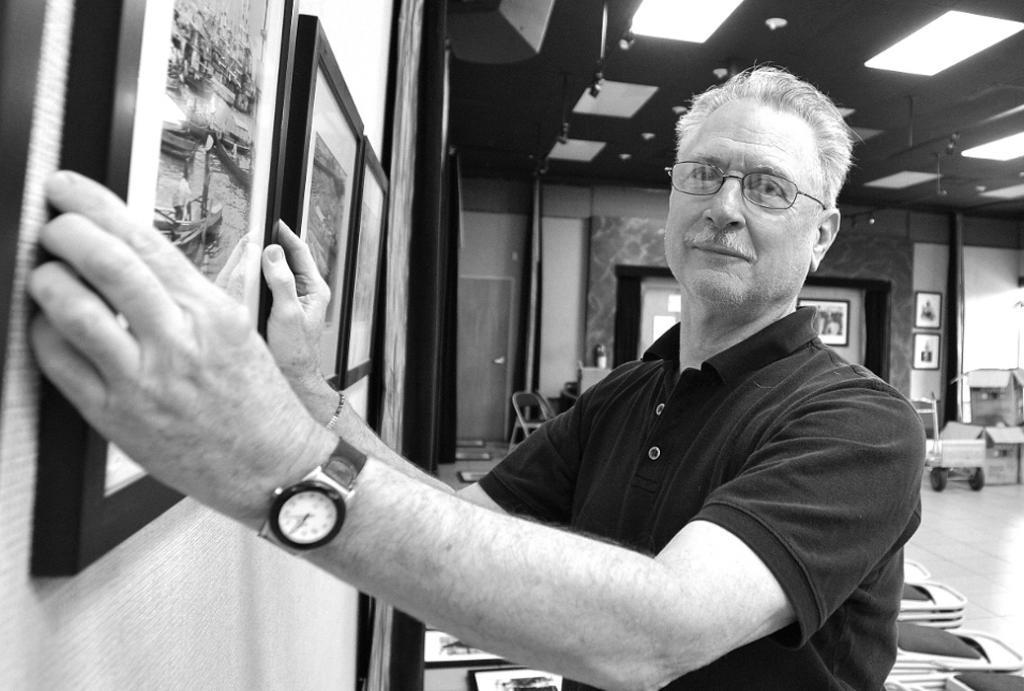Please provide a concise description of this image. This is a black and white image and here we can see a person wearing glasses and holding a frame. In the background, there are lights and we can see frames on the wall and there is a chair and we can see some objects. At the top, there is a roof and at the bottom, there is a floor. 